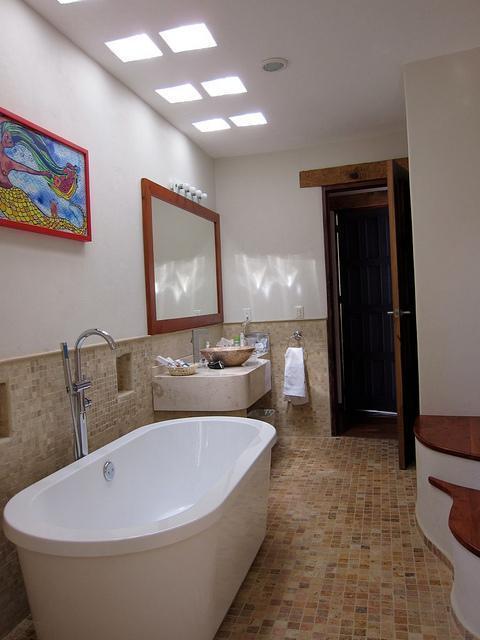How many cups have yellow flowers in them?
Give a very brief answer. 0. 